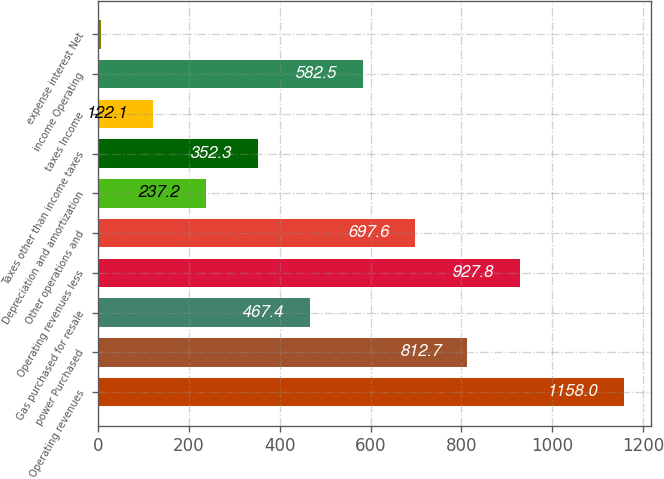<chart> <loc_0><loc_0><loc_500><loc_500><bar_chart><fcel>Operating revenues<fcel>power Purchased<fcel>Gas purchased for resale<fcel>Operating revenues less<fcel>Other operations and<fcel>Depreciation and amortization<fcel>Taxes other than income taxes<fcel>taxes Income<fcel>income Operating<fcel>expense interest Net<nl><fcel>1158<fcel>812.7<fcel>467.4<fcel>927.8<fcel>697.6<fcel>237.2<fcel>352.3<fcel>122.1<fcel>582.5<fcel>7<nl></chart> 